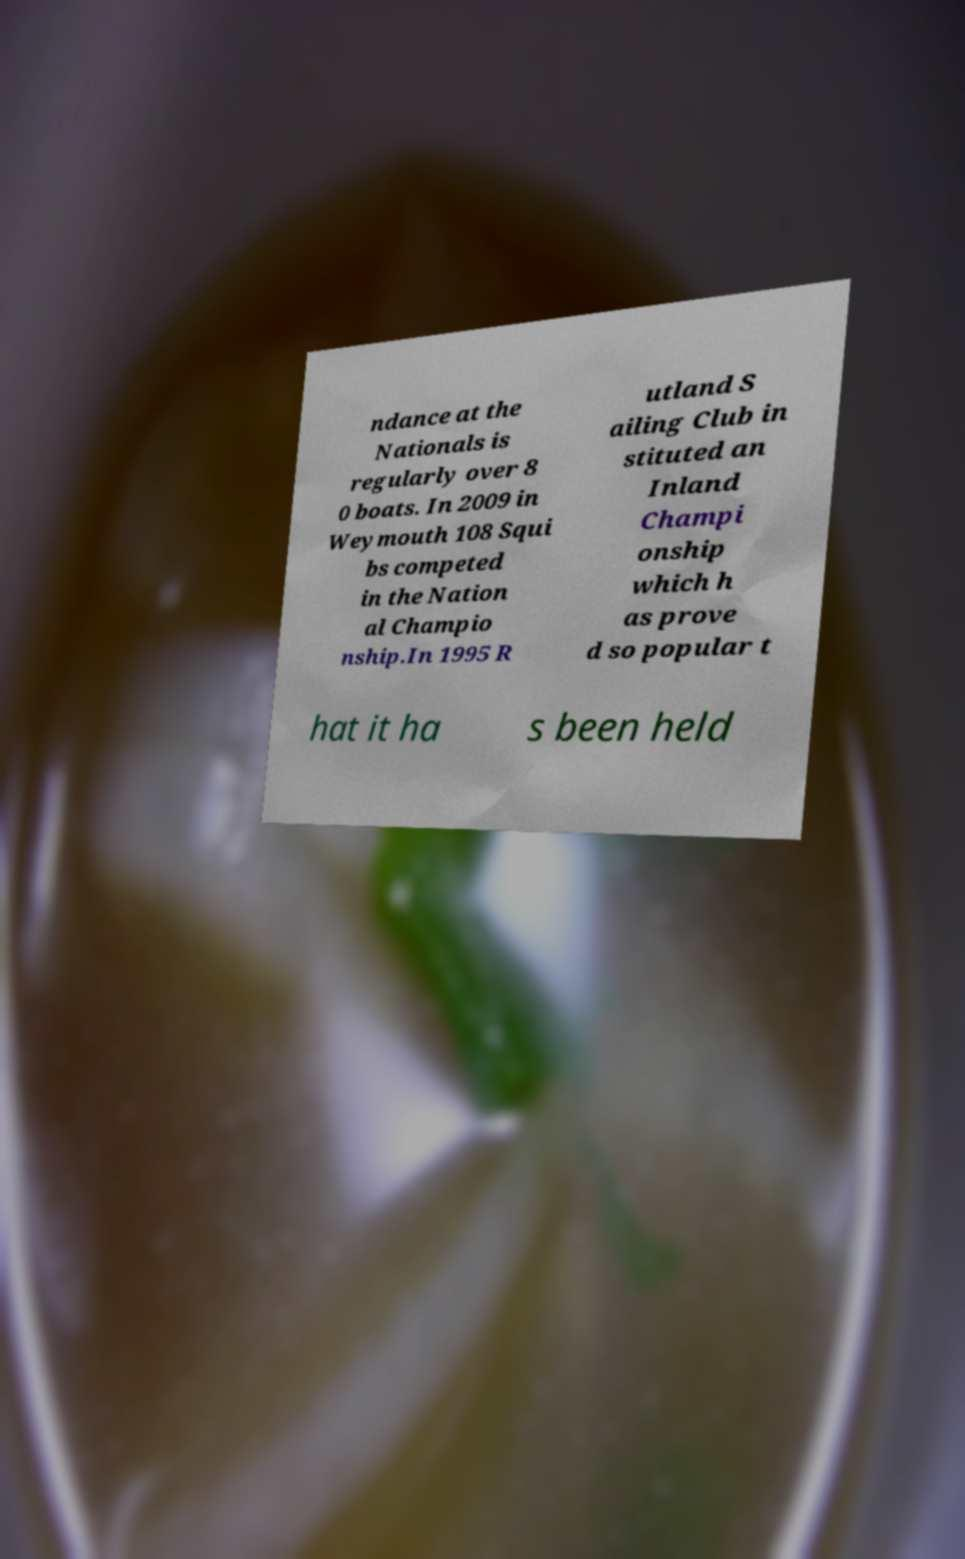What messages or text are displayed in this image? I need them in a readable, typed format. ndance at the Nationals is regularly over 8 0 boats. In 2009 in Weymouth 108 Squi bs competed in the Nation al Champio nship.In 1995 R utland S ailing Club in stituted an Inland Champi onship which h as prove d so popular t hat it ha s been held 